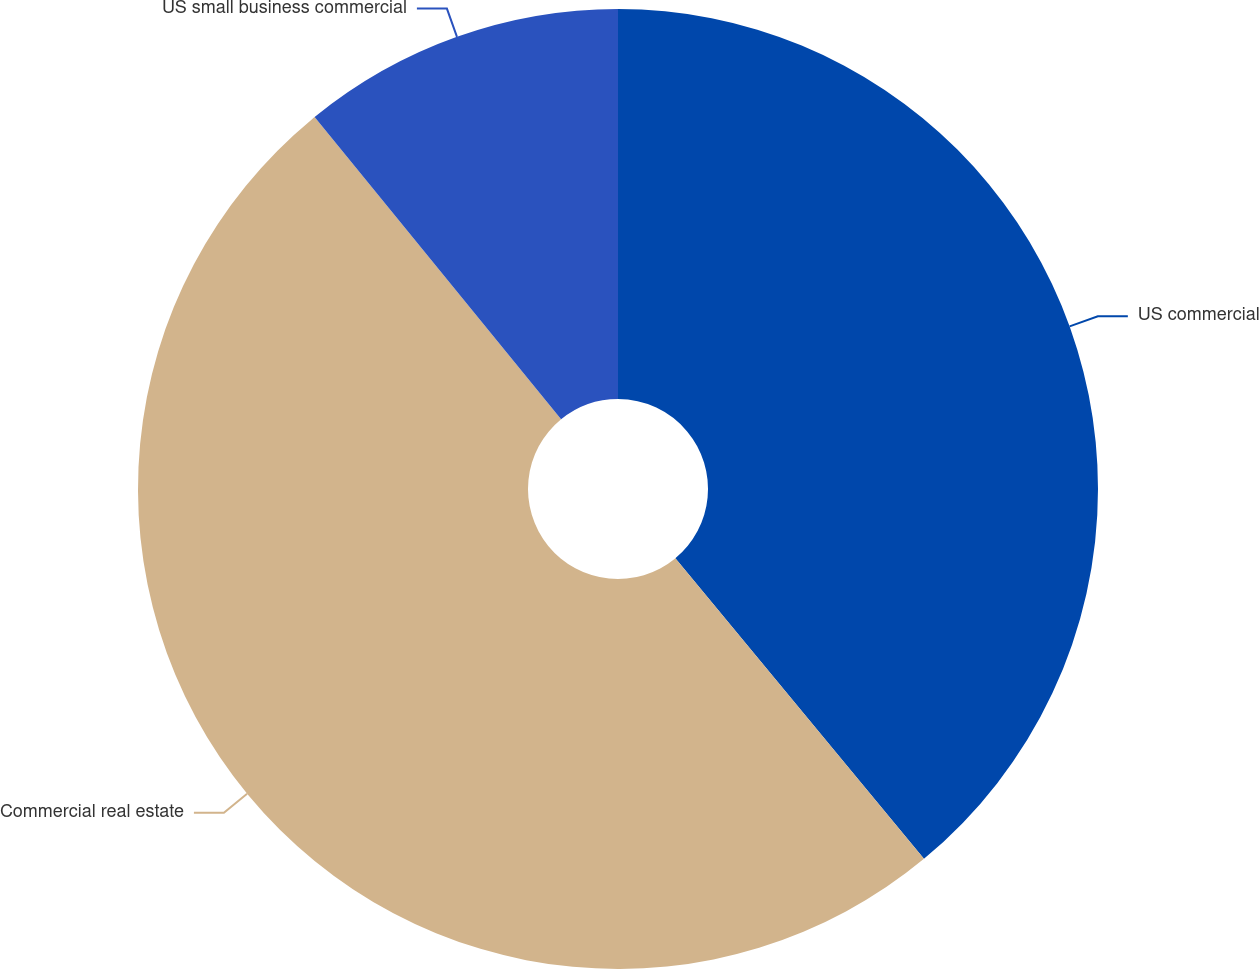<chart> <loc_0><loc_0><loc_500><loc_500><pie_chart><fcel>US commercial<fcel>Commercial real estate<fcel>US small business commercial<nl><fcel>39.0%<fcel>50.11%<fcel>10.89%<nl></chart> 